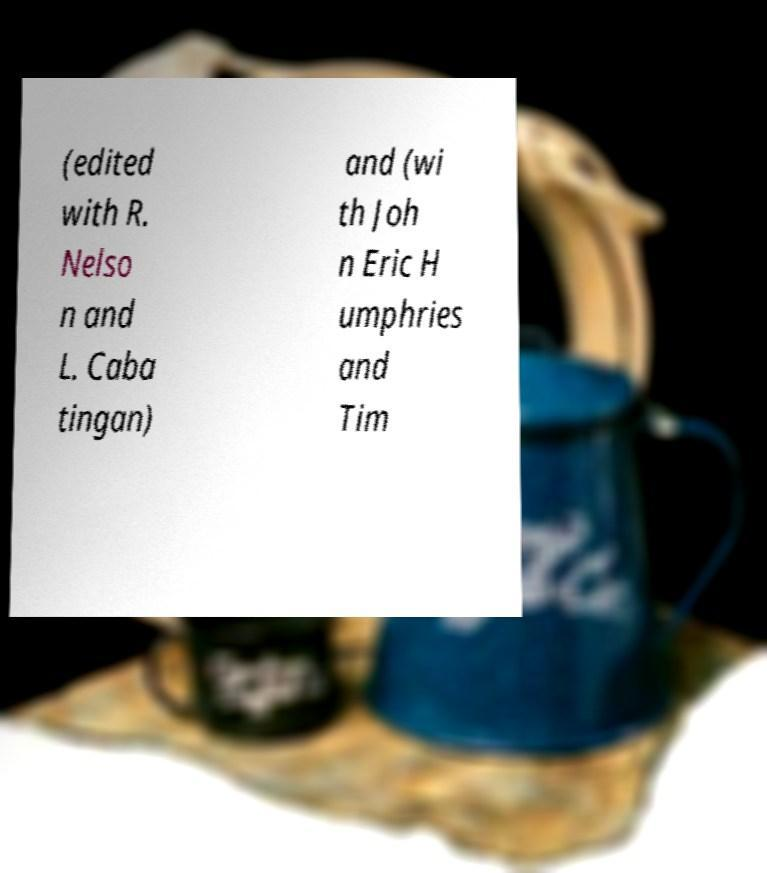Can you accurately transcribe the text from the provided image for me? (edited with R. Nelso n and L. Caba tingan) and (wi th Joh n Eric H umphries and Tim 